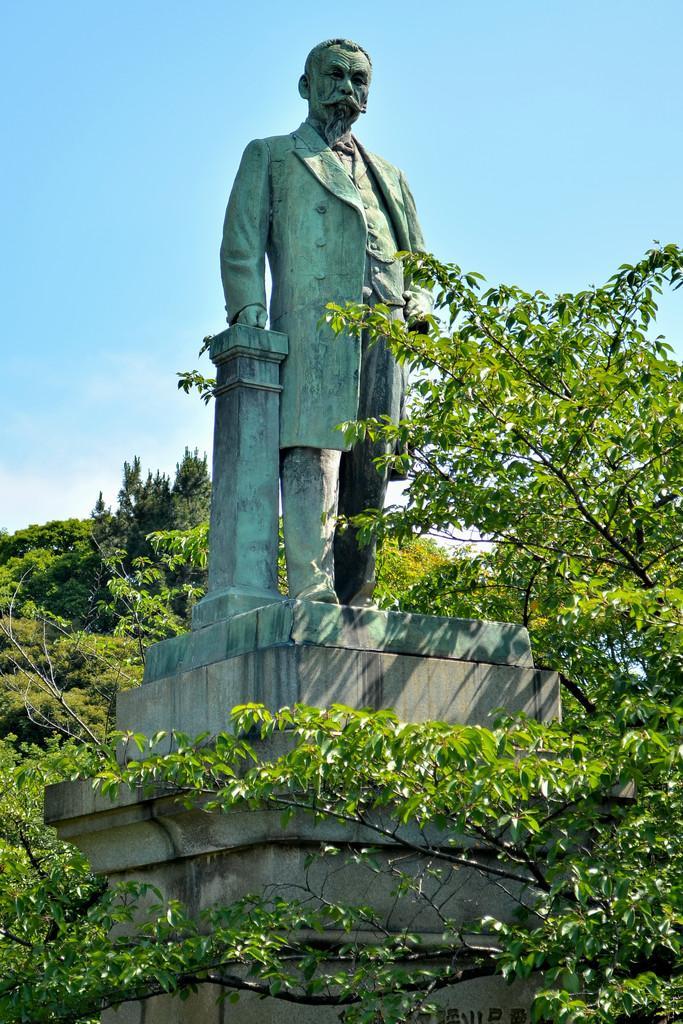Describe this image in one or two sentences. In this image, we can see some branches. There is a statue in the middle of the image. In the background of the image, there is a sky. 